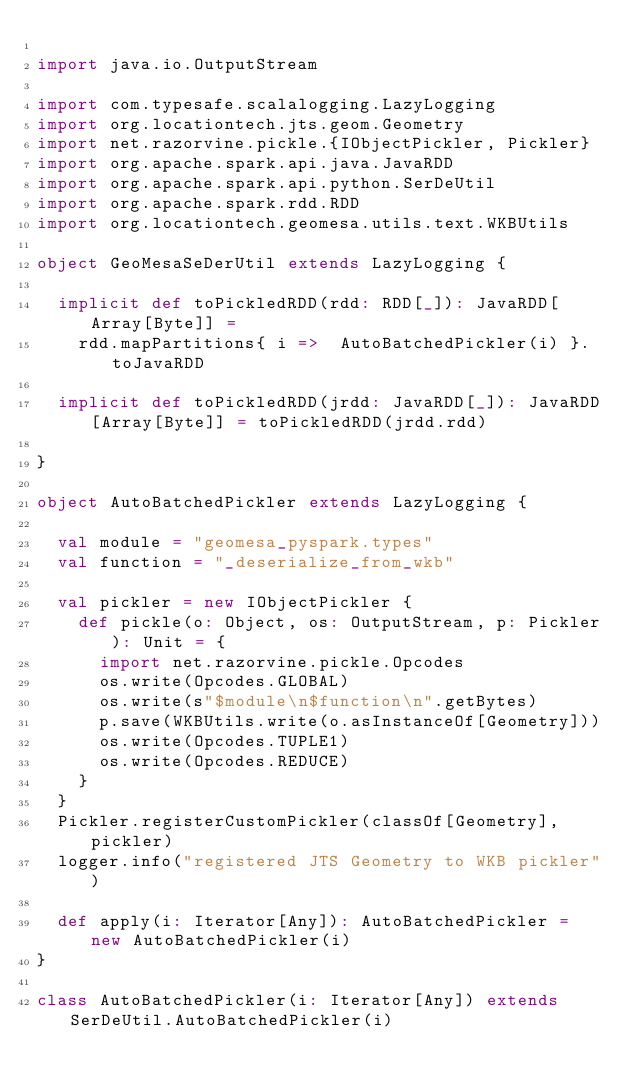<code> <loc_0><loc_0><loc_500><loc_500><_Scala_>
import java.io.OutputStream

import com.typesafe.scalalogging.LazyLogging
import org.locationtech.jts.geom.Geometry
import net.razorvine.pickle.{IObjectPickler, Pickler}
import org.apache.spark.api.java.JavaRDD
import org.apache.spark.api.python.SerDeUtil
import org.apache.spark.rdd.RDD
import org.locationtech.geomesa.utils.text.WKBUtils

object GeoMesaSeDerUtil extends LazyLogging {

  implicit def toPickledRDD(rdd: RDD[_]): JavaRDD[Array[Byte]] =
    rdd.mapPartitions{ i =>  AutoBatchedPickler(i) }.toJavaRDD

  implicit def toPickledRDD(jrdd: JavaRDD[_]): JavaRDD[Array[Byte]] = toPickledRDD(jrdd.rdd)

}

object AutoBatchedPickler extends LazyLogging {

  val module = "geomesa_pyspark.types"
  val function = "_deserialize_from_wkb"

  val pickler = new IObjectPickler {
    def pickle(o: Object, os: OutputStream, p: Pickler): Unit = {
      import net.razorvine.pickle.Opcodes
      os.write(Opcodes.GLOBAL)
      os.write(s"$module\n$function\n".getBytes)
      p.save(WKBUtils.write(o.asInstanceOf[Geometry]))
      os.write(Opcodes.TUPLE1)
      os.write(Opcodes.REDUCE)
    }
  }
  Pickler.registerCustomPickler(classOf[Geometry], pickler)
  logger.info("registered JTS Geometry to WKB pickler")

  def apply(i: Iterator[Any]): AutoBatchedPickler =  new AutoBatchedPickler(i)
}

class AutoBatchedPickler(i: Iterator[Any]) extends SerDeUtil.AutoBatchedPickler(i)
</code> 